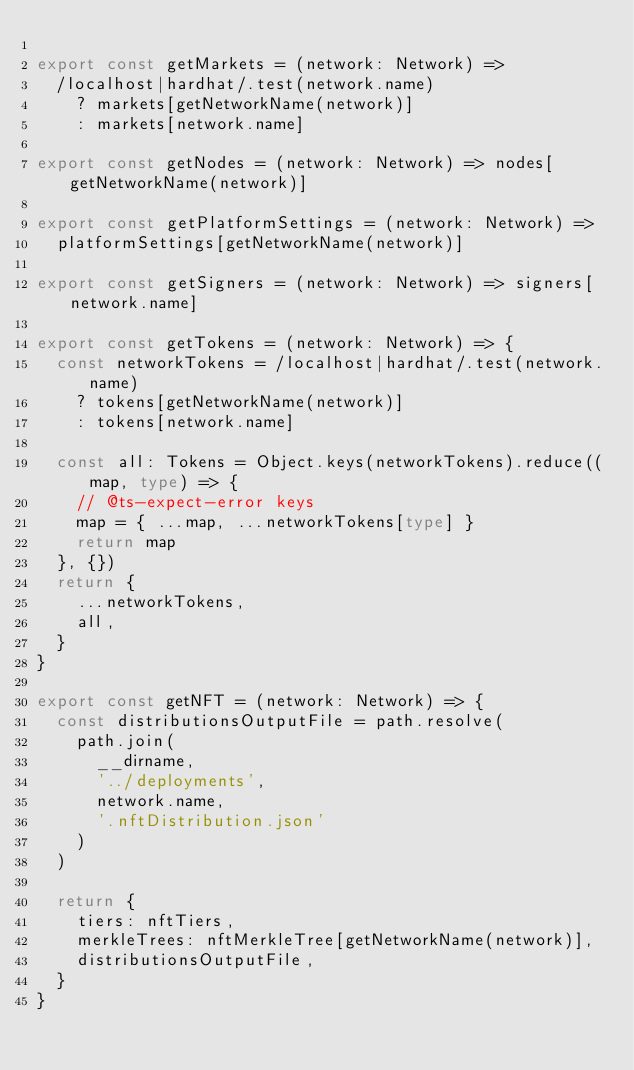Convert code to text. <code><loc_0><loc_0><loc_500><loc_500><_TypeScript_>
export const getMarkets = (network: Network) =>
  /localhost|hardhat/.test(network.name)
    ? markets[getNetworkName(network)]
    : markets[network.name]

export const getNodes = (network: Network) => nodes[getNetworkName(network)]

export const getPlatformSettings = (network: Network) =>
  platformSettings[getNetworkName(network)]

export const getSigners = (network: Network) => signers[network.name]

export const getTokens = (network: Network) => {
  const networkTokens = /localhost|hardhat/.test(network.name)
    ? tokens[getNetworkName(network)]
    : tokens[network.name]

  const all: Tokens = Object.keys(networkTokens).reduce((map, type) => {
    // @ts-expect-error keys
    map = { ...map, ...networkTokens[type] }
    return map
  }, {})
  return {
    ...networkTokens,
    all,
  }
}

export const getNFT = (network: Network) => {
  const distributionsOutputFile = path.resolve(
    path.join(
      __dirname,
      '../deployments',
      network.name,
      '.nftDistribution.json'
    )
  )

  return {
    tiers: nftTiers,
    merkleTrees: nftMerkleTree[getNetworkName(network)],
    distributionsOutputFile,
  }
}
</code> 